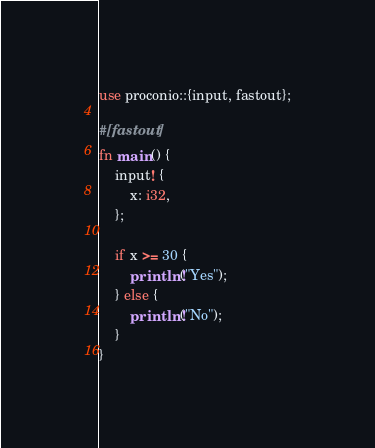Convert code to text. <code><loc_0><loc_0><loc_500><loc_500><_Rust_>use proconio::{input, fastout};

#[fastout]
fn main() {
    input! {
        x: i32,
    };

    if x >= 30 {
        println!("Yes");
    } else {
        println!("No");
    }
}</code> 